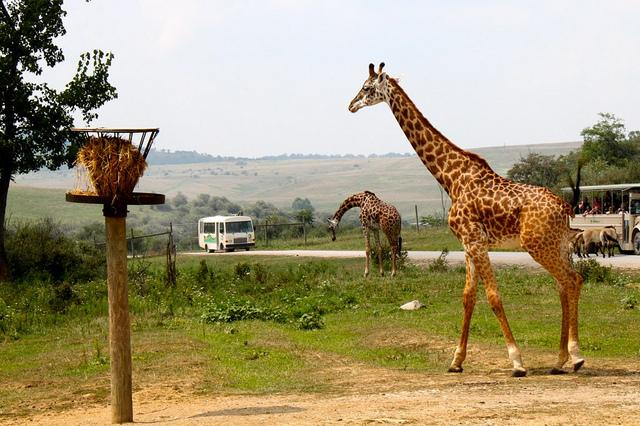What are the people on the vehicle to the right involved in?

Choices:
A) safari
B) hitch hiking
C) school ride
D) selling safari 